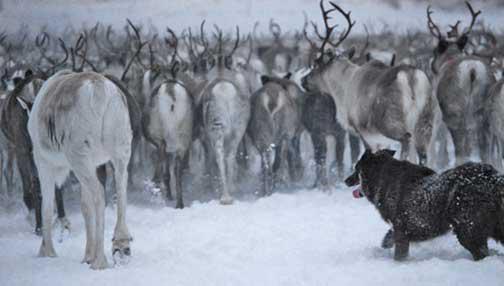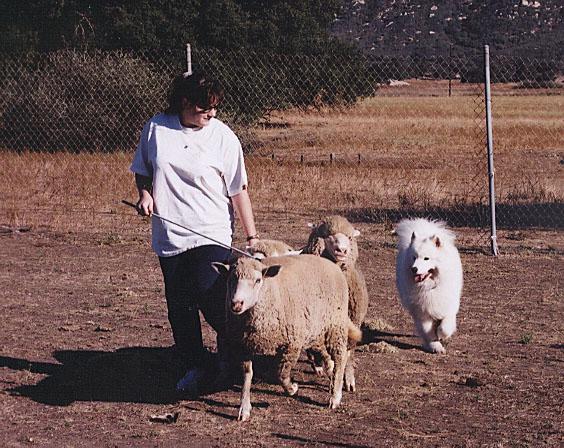The first image is the image on the left, the second image is the image on the right. Assess this claim about the two images: "At least one image shows a woman holding a stick while working with sheep and dog.". Correct or not? Answer yes or no. Yes. 